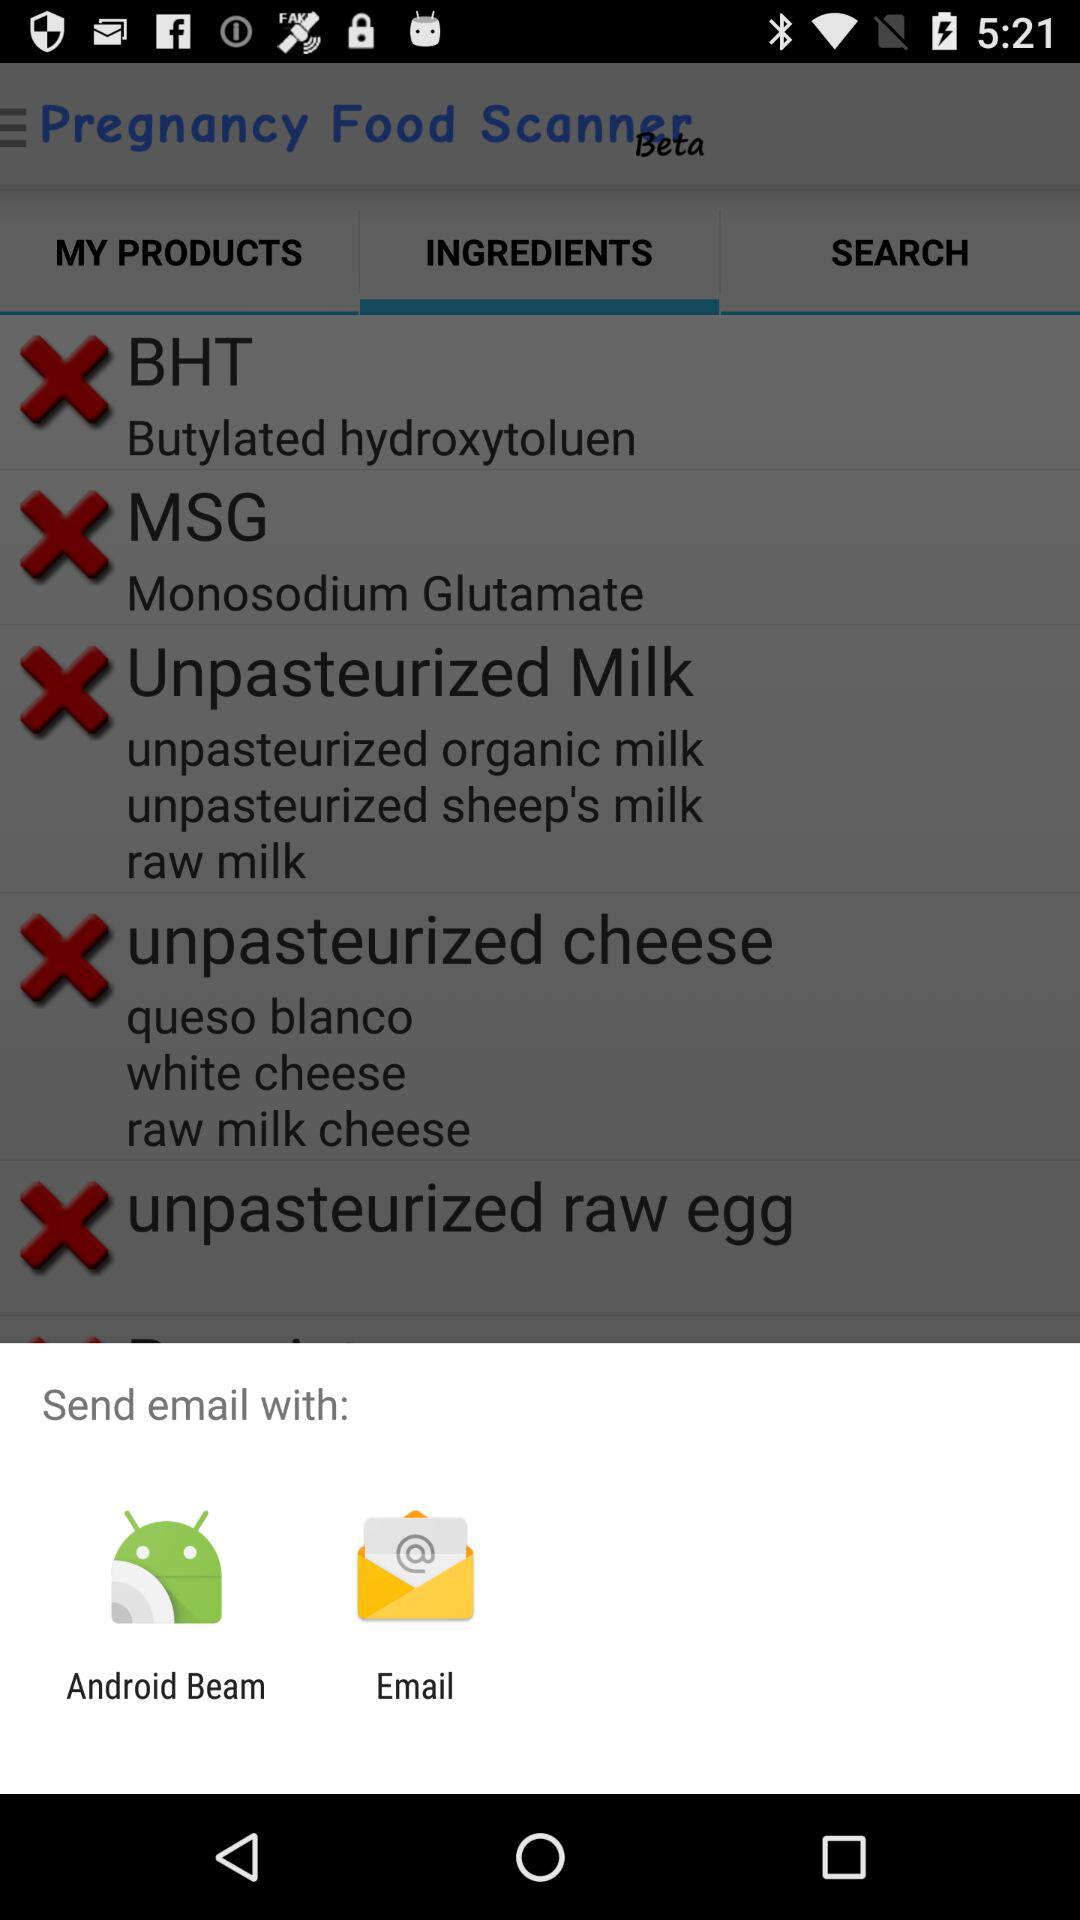Through what applications can we send email with? The applications are "Android Beam" and "Email". 